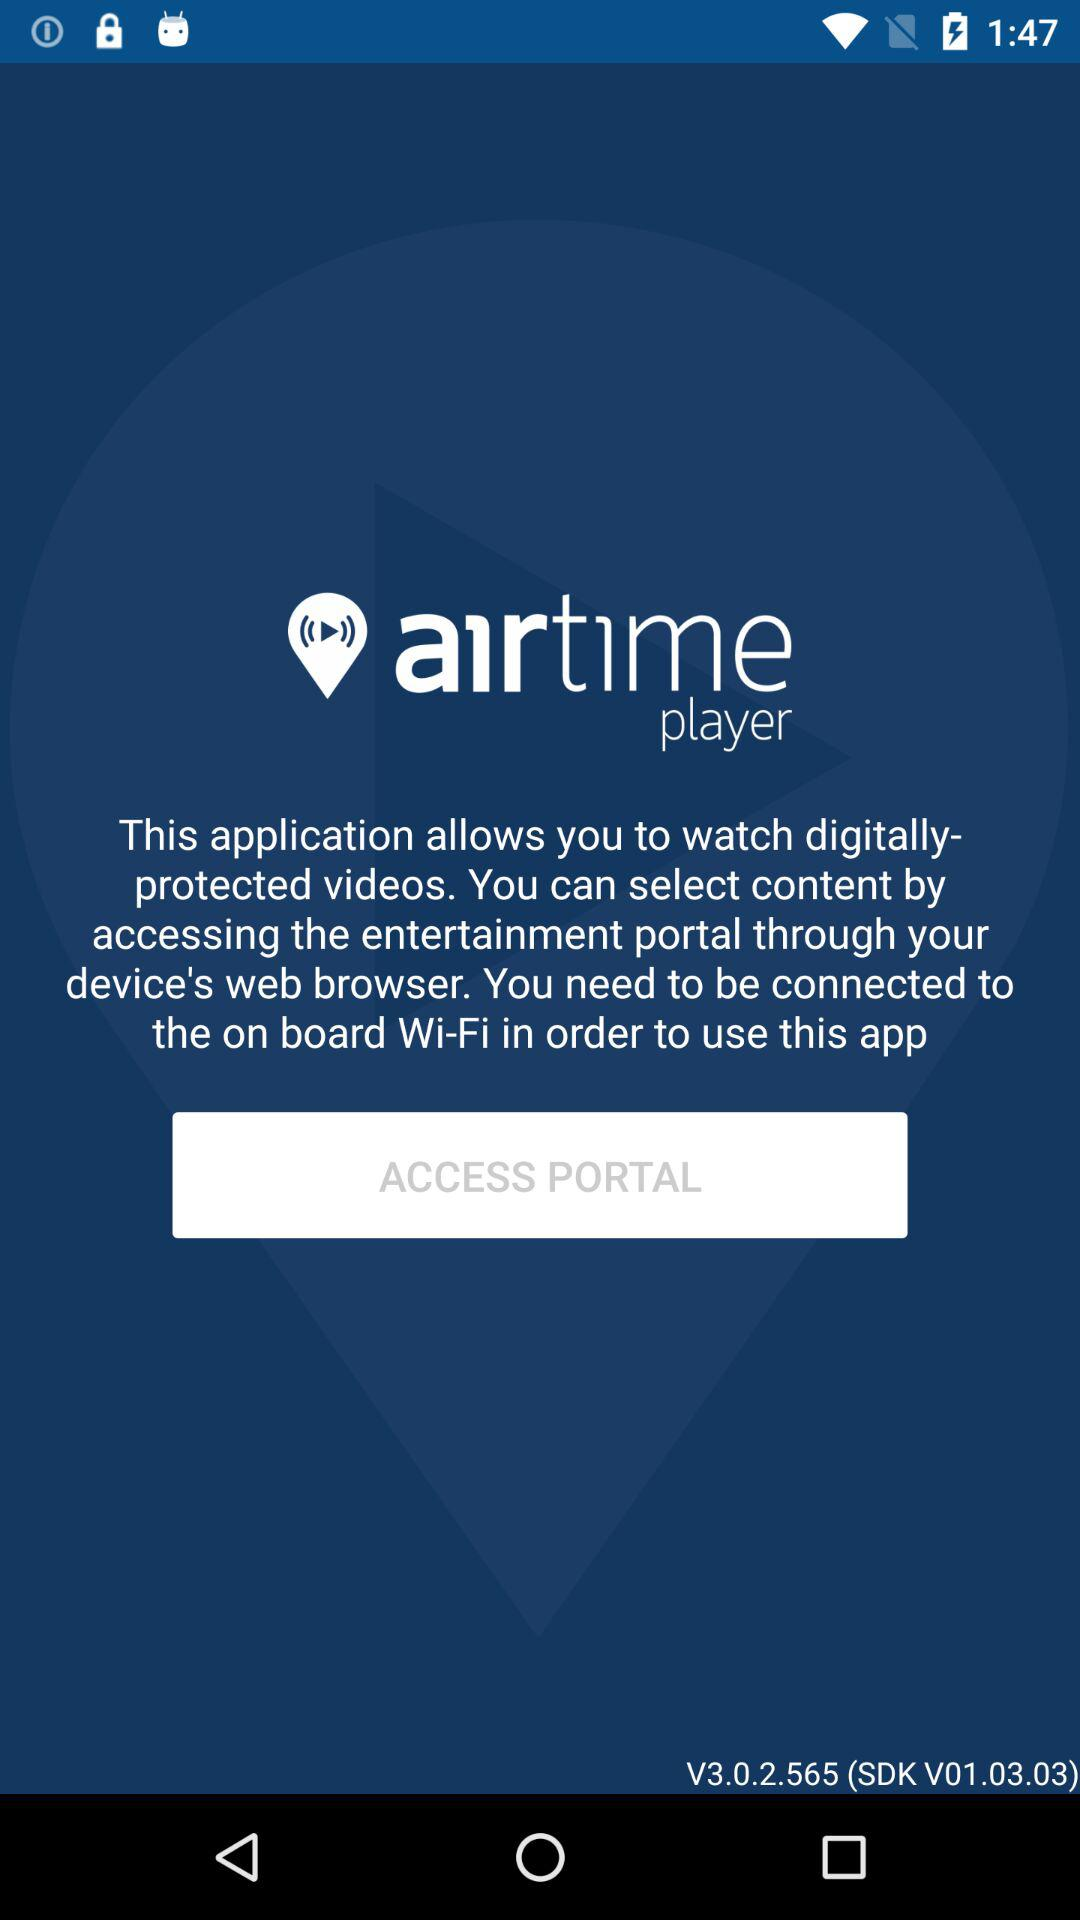What is the version of the application? The version of the application is V3.0.2.565 (SDK V01.03.03). 